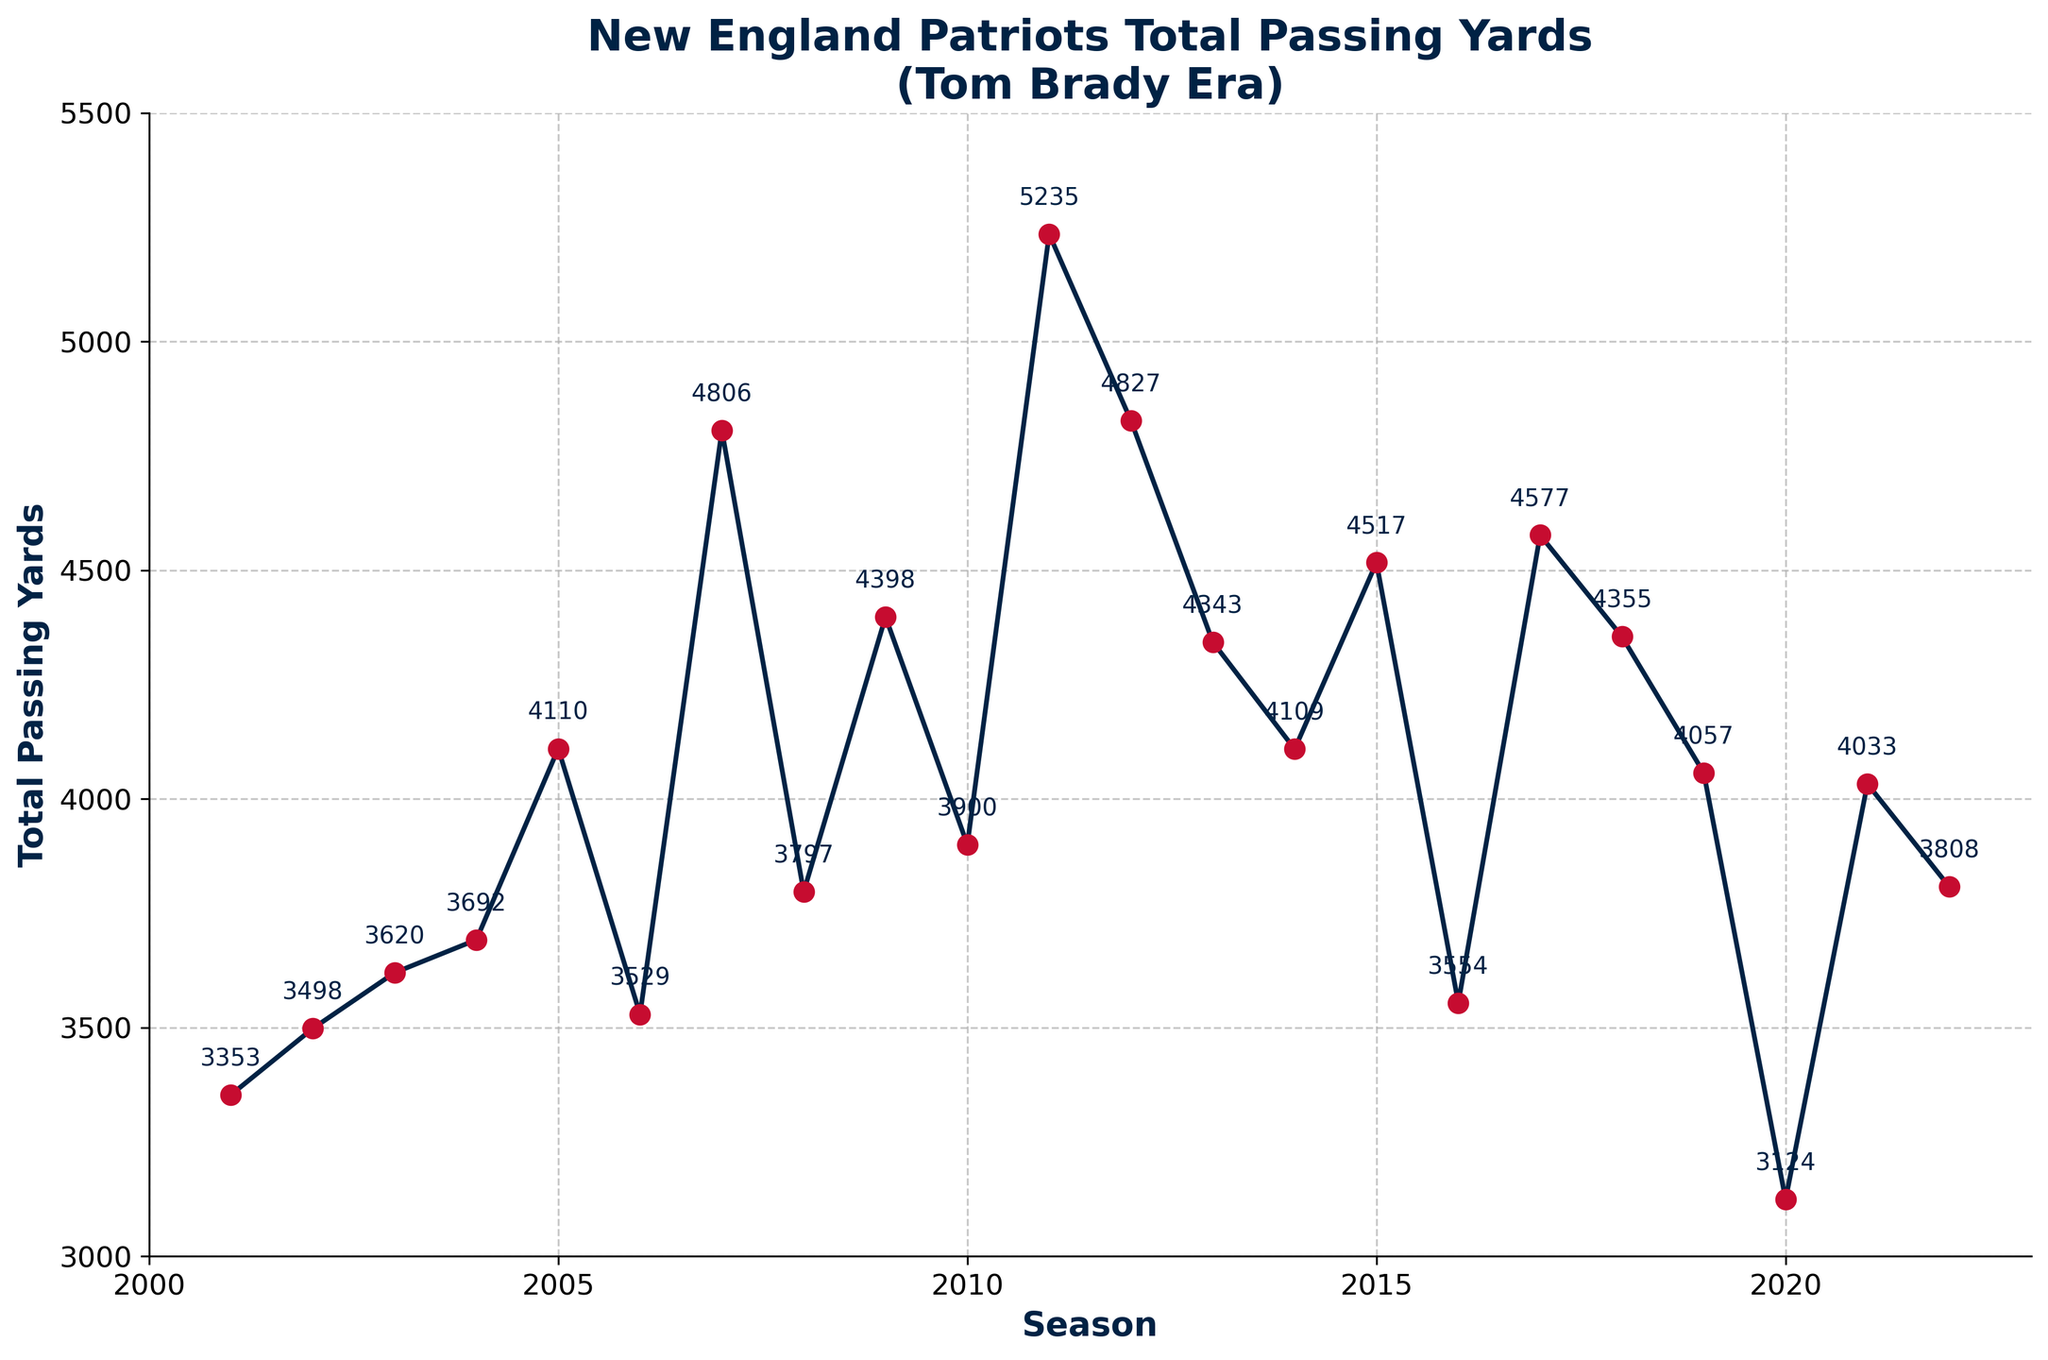Which season had the highest total passing yards? The highest point on the line chart indicates the season with the highest total passing yards. The value at this point is labeled as 5235 yards, which corresponds to the 2011 season.
Answer: 2011 What is the total passing yards difference between the 2007 and 2018 seasons? From the chart, the total passing yards for 2007 is 4806, and for 2018, it is 4355. Subtracting these gives 4806 - 4355 = 451.
Answer: 451 Which season experienced the most significant drop in total passing yards compared to the previous season? Comparing consecutive seasons, the most significant drop appears between 2011 and 2012 as indicated by the steepest decline. In 2011, the total passing yards were 5235, and in 2012, they were 4827. The drop is 5235 - 4827 = 408 yards.
Answer: 2011 to 2012 Were the total passing yards in the 2016 season greater than or less than those in the 2019 season? The chart shows that the total passing yards for 2016 are 3554, and for 2019, they are 4057. Since 3554 is less than 4057, the passing yards in 2016 were less than those in 2019.
Answer: Less What is the average total passing yards from 2001 to 2005? Summing up the total passing yards from 2001 to 2005: 3353 + 3498 + 3620 + 3692 + 4110 = 18273. Dividing by 5 (number of seasons) gives the average: 18273 / 5 = 3654.6.
Answer: 3654.6 What are the total passing yards in the first season without Tom Brady (2020)? According to the chart, the total passing yards in the 2020 season are labeled as 3124.
Answer: 3124 Which two consecutive seasons had the smallest change in total passing yards? Observing the chart, the smallest change seems to occur between the 2002 and 2003 seasons, where the total passing yards are 3498 and 3620 respectively. The difference is 3620 - 3498 = 122.
Answer: 2002 to 2003 What was the approximate total passing yards during Tom Brady's first season as a starting quarterback? The chart shows the total passing yards for the 2001 season, which is Brady's first season as the starting quarterback, as 3353.
Answer: 3353 How do the total passing yards in 2015 compare to those in 2017? Looking at the chart, the total passing yards for 2015 are 4517, and for 2017, they are 4577. Since 4577 is slightly higher than 4517, the total passing yards in 2017 are greater than those in 2015.
Answer: Greater What is the median total passing yards from 2010 to 2022? The total passing yards for the seasons 2010 to 2022 are 3900, 5235, 4827, 4343, 4109, 4517, 3554, 4577, 4355, 4057, 3124, 4033, and 3808. Arranging these in ascending order: 3124, 3554, 3808, 3900, 4033, 4057, 4109, 4343, 4355, 4517, 4577, 4827, 5235. The median is the middle value of this ordered list, which is 4109.
Answer: 4109 